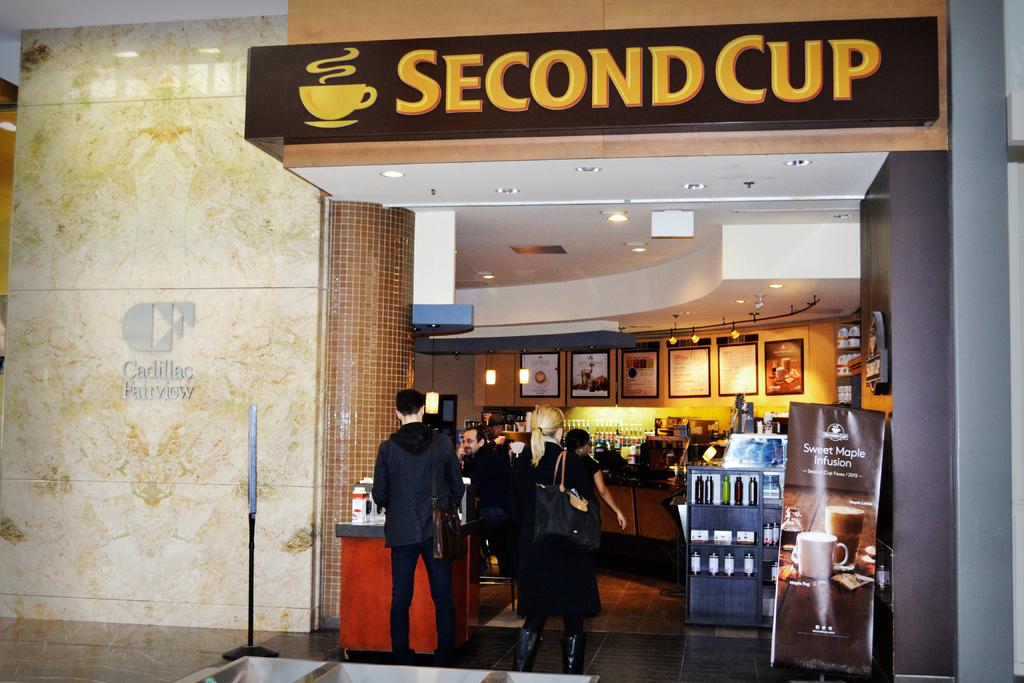What is the name of this cafe?
Provide a succinct answer. Second cup. What is the name of the coffee shop?
Offer a very short reply. Second cup. 